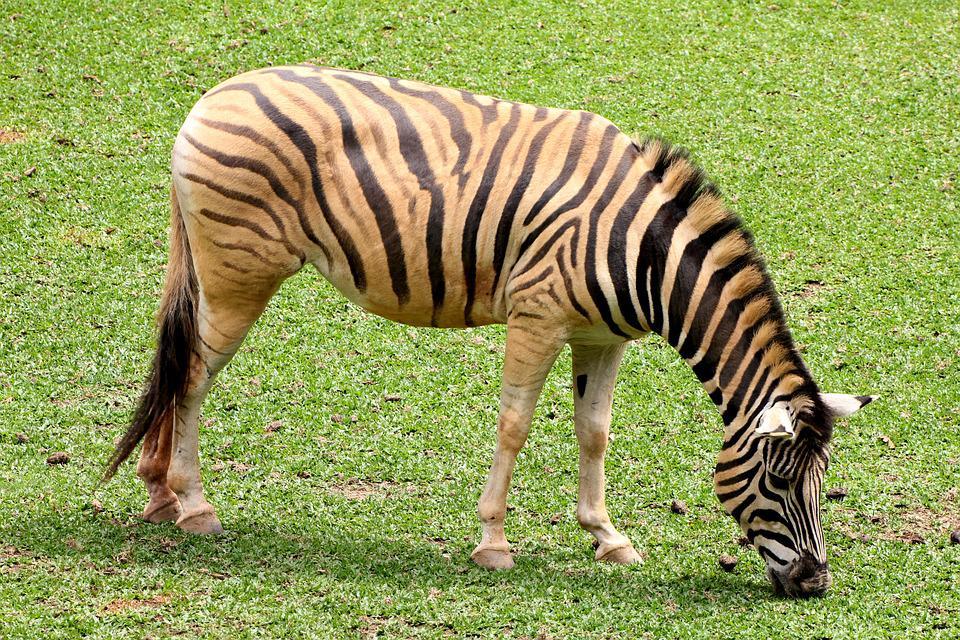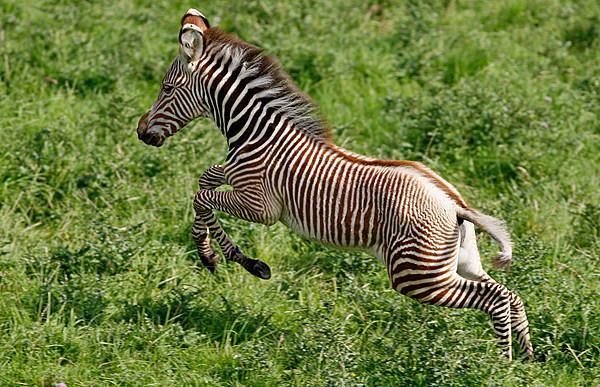The first image is the image on the left, the second image is the image on the right. Considering the images on both sides, is "A zebra has its head down eating the very short green grass." valid? Answer yes or no. Yes. The first image is the image on the left, the second image is the image on the right. Assess this claim about the two images: "In one image a lone zebra is standing and grazing in the grass.". Correct or not? Answer yes or no. Yes. 